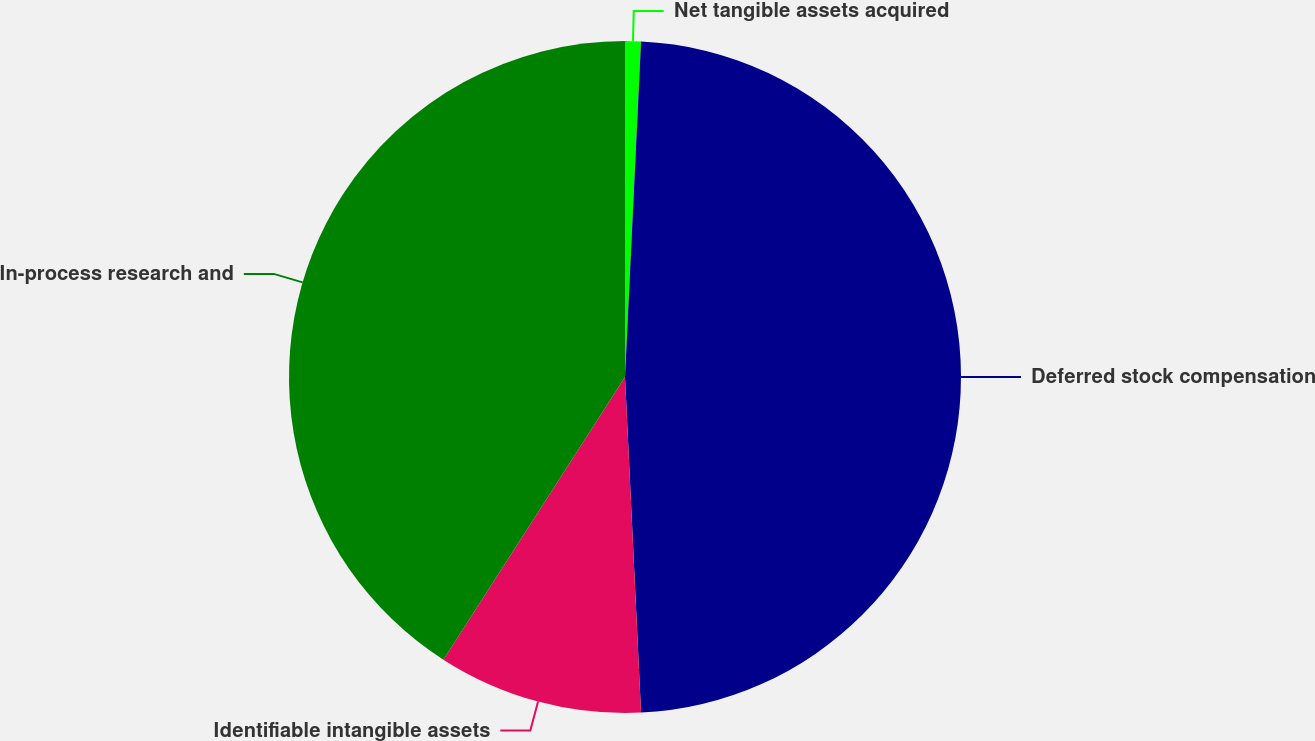Convert chart. <chart><loc_0><loc_0><loc_500><loc_500><pie_chart><fcel>Net tangible assets acquired<fcel>Deferred stock compensation<fcel>Identifiable intangible assets<fcel>In-process research and<nl><fcel>0.76%<fcel>48.48%<fcel>9.85%<fcel>40.91%<nl></chart> 